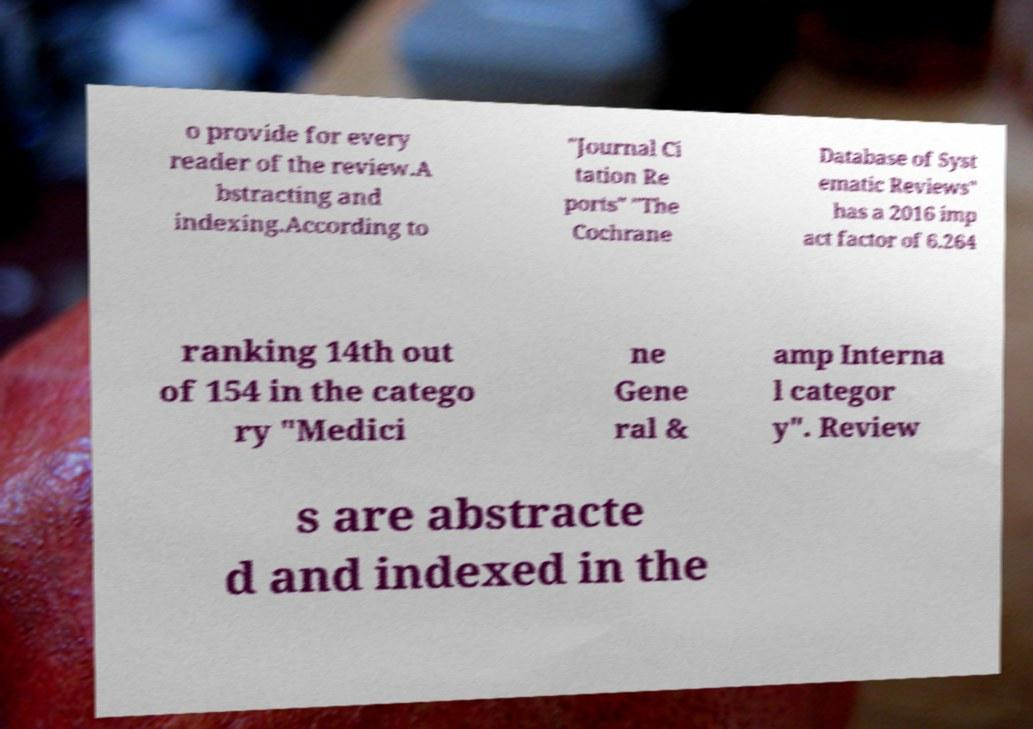For documentation purposes, I need the text within this image transcribed. Could you provide that? o provide for every reader of the review.A bstracting and indexing.According to "Journal Ci tation Re ports" "The Cochrane Database of Syst ematic Reviews" has a 2016 imp act factor of 6.264 ranking 14th out of 154 in the catego ry "Medici ne Gene ral & amp Interna l categor y". Review s are abstracte d and indexed in the 